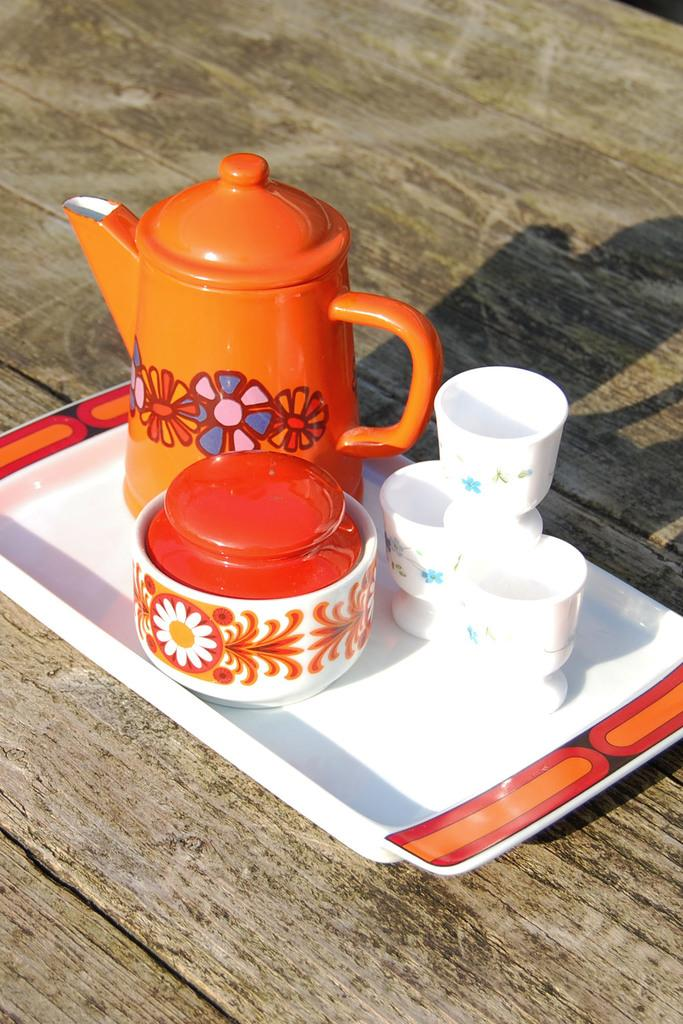What piece of furniture is present in the image? There is a table in the image. What is placed on the table? There is a jug, cups, and a bowl with a lid on a tray on the table. Can you describe the bowl with a lid on the tray? The bowl with a lid is on a tray on the table. What type of stamp can be seen on the jug in the image? There is no stamp visible on the jug in the image. 